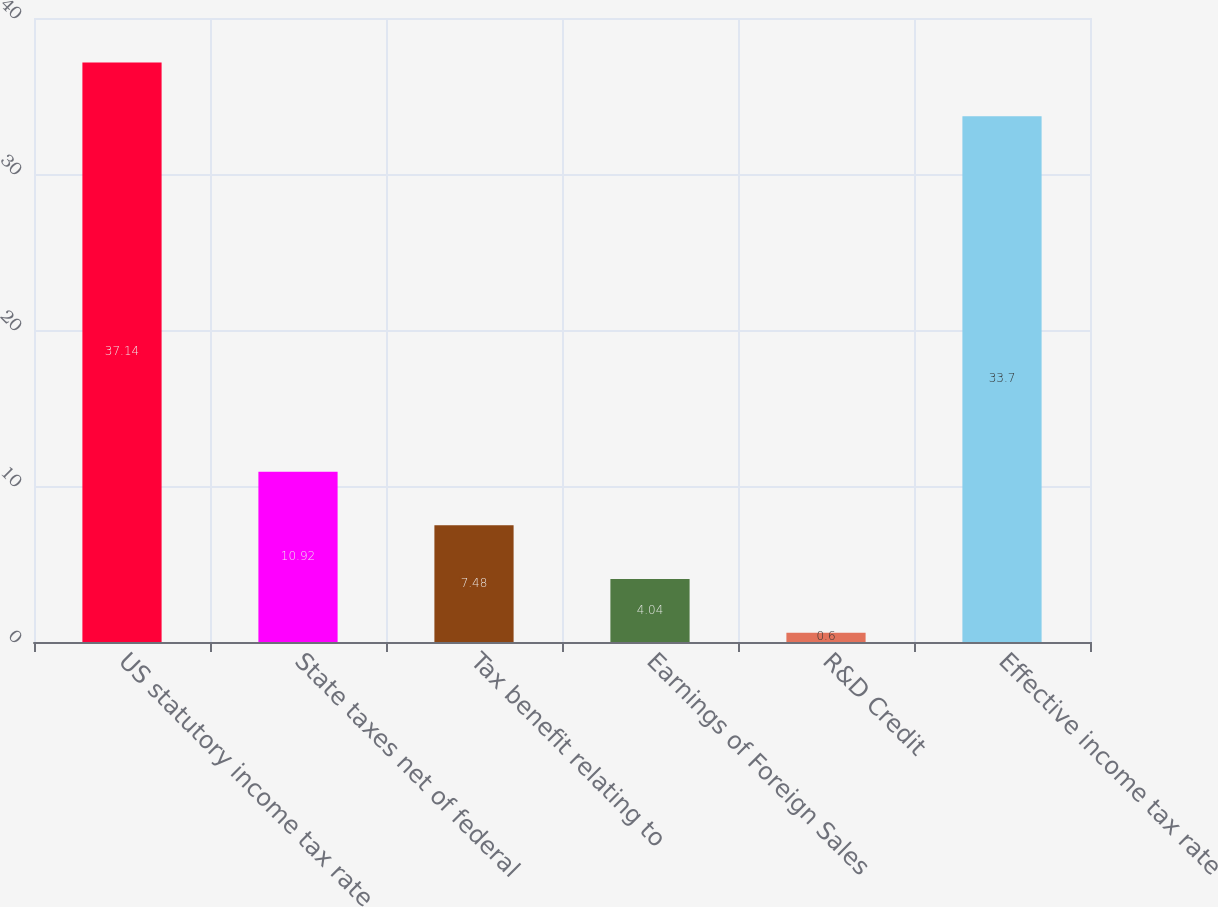Convert chart to OTSL. <chart><loc_0><loc_0><loc_500><loc_500><bar_chart><fcel>US statutory income tax rate<fcel>State taxes net of federal<fcel>Tax benefit relating to<fcel>Earnings of Foreign Sales<fcel>R&D Credit<fcel>Effective income tax rate<nl><fcel>37.14<fcel>10.92<fcel>7.48<fcel>4.04<fcel>0.6<fcel>33.7<nl></chart> 